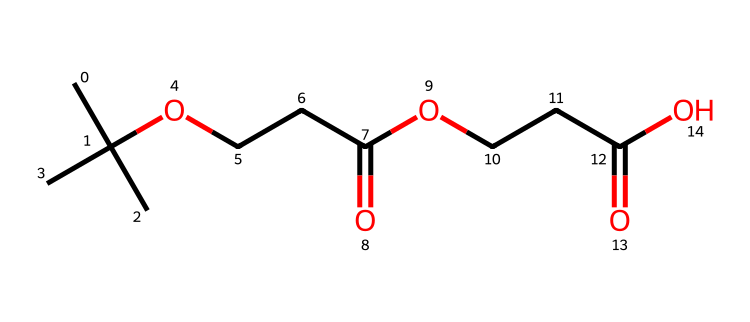What is the functional group present in this chemical? The chemical contains carboxylic acid functional groups, as indicated by the “-COOH” patterns in the structure.
Answer: carboxylic acid How many carbon atoms are present in the structure? By counting all the carbon (C) atoms in the chemical structure, there are 9 carbon atoms total.
Answer: 9 What type of chemical is this compound classified as? The structure shows elements typical of imides, specifically based on the presence of nitrogen and carbonyl groups.
Answer: imide What is the total number of oxygen atoms in this molecule? The structure contains four oxygen (O) atoms, appearing in two carboxylic acid groups within the compound.
Answer: 4 Can you identify any potential applications of this chemical in rugby jerseys? The chemical's properties, including its ability to wick moisture, suggest it may enhance sweat management in fabrics, promoting comfort in rugby jerseys.
Answer: moisture-wicking 